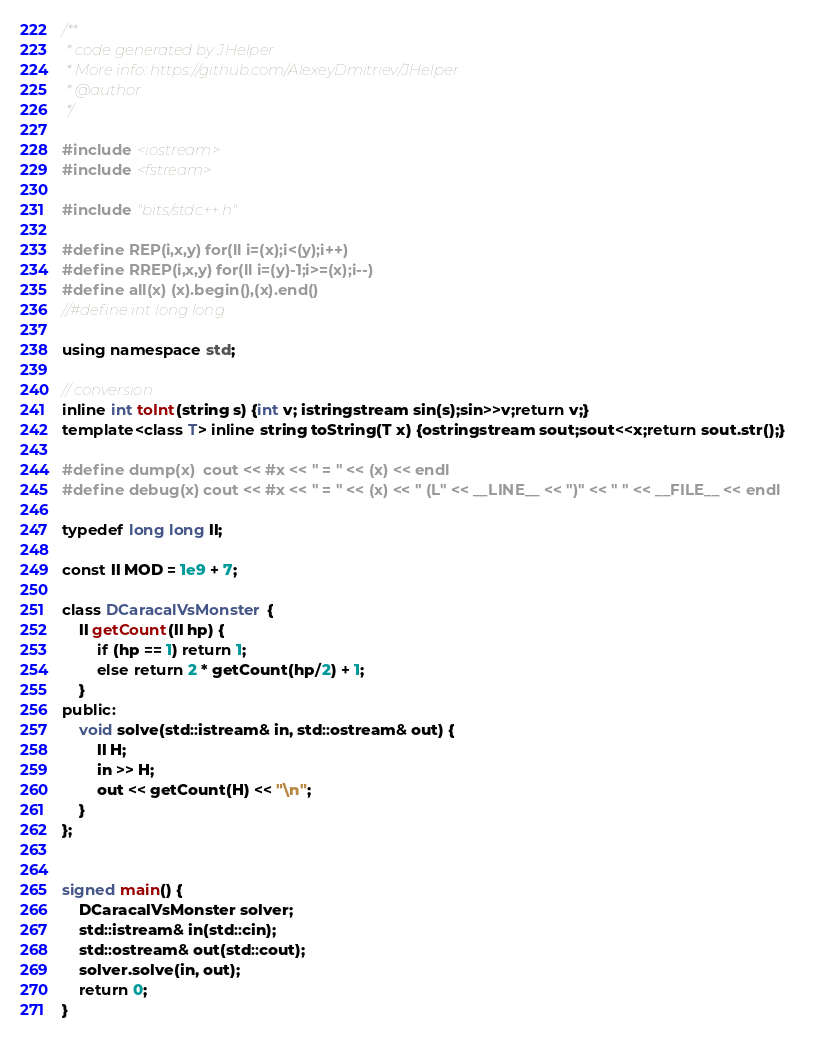Convert code to text. <code><loc_0><loc_0><loc_500><loc_500><_C++_>/**
 * code generated by JHelper
 * More info: https://github.com/AlexeyDmitriev/JHelper
 * @author
 */

#include <iostream>
#include <fstream>

#include "bits/stdc++.h"

#define REP(i,x,y) for(ll i=(x);i<(y);i++)
#define RREP(i,x,y) for(ll i=(y)-1;i>=(x);i--)
#define all(x) (x).begin(),(x).end()
//#define int long long

using namespace std;

// conversion
inline int toInt(string s) {int v; istringstream sin(s);sin>>v;return v;}
template<class T> inline string toString(T x) {ostringstream sout;sout<<x;return sout.str();}

#define dump(x)  cout << #x << " = " << (x) << endl
#define debug(x) cout << #x << " = " << (x) << " (L" << __LINE__ << ")" << " " << __FILE__ << endl

typedef long long ll;

const ll MOD = 1e9 + 7;

class DCaracalVsMonster {
    ll getCount(ll hp) {
        if (hp == 1) return 1;
        else return 2 * getCount(hp/2) + 1;
    }
public:
    void solve(std::istream& in, std::ostream& out) {
        ll H;
        in >> H;
        out << getCount(H) << "\n";
    }
};


signed main() {
    DCaracalVsMonster solver;
    std::istream& in(std::cin);
	std::ostream& out(std::cout);
	solver.solve(in, out);
	return 0;
}
</code> 